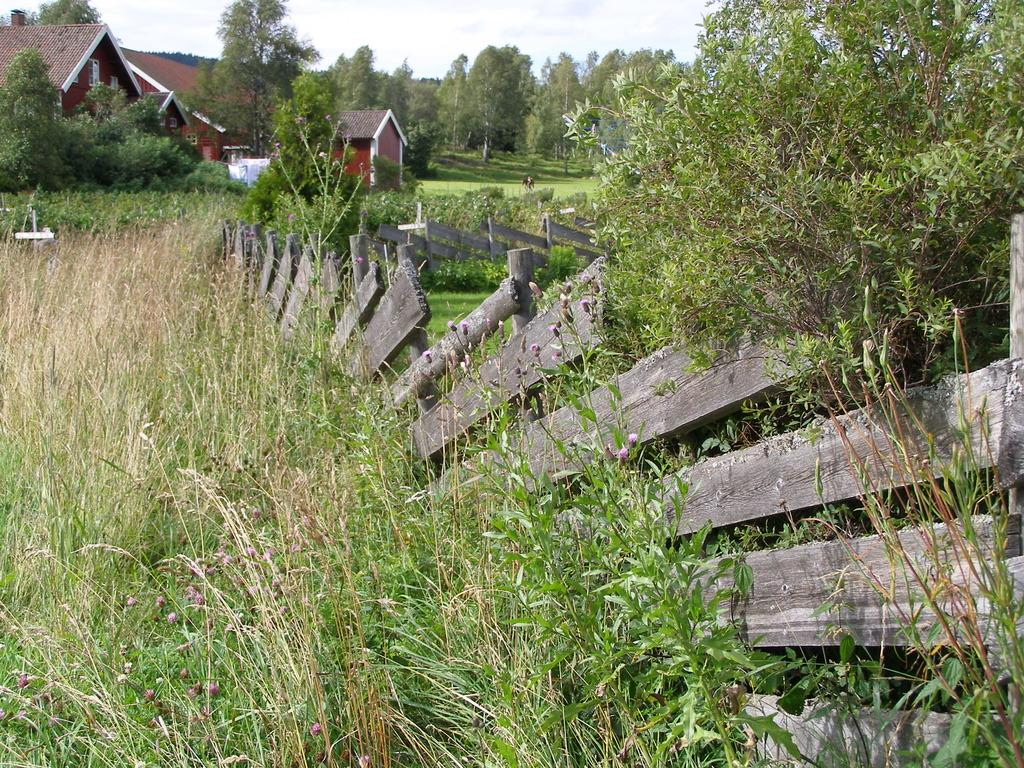What type of vegetation is present in the image? There is grass and plants in the image. What kind of barrier can be seen in the image? There is a fence in the image. What structures are visible in the background of the image? There are houses and trees in the background of the image. What part of the natural environment is visible in the image? The sky is visible in the background of the image. Can you see any worms crawling on the grass in the image? There are no worms visible in the image; it only shows grass, plants, a fence, houses, trees, and the sky. Is there a cave in the image where people can run and hide? There is no cave present in the image, and it does not depict any people running or hiding. 